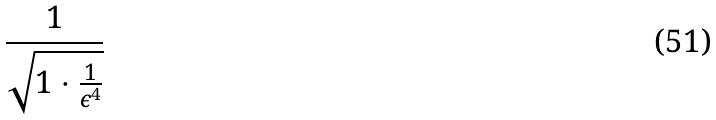<formula> <loc_0><loc_0><loc_500><loc_500>\frac { 1 } { \sqrt { 1 \cdot \frac { 1 } { \epsilon ^ { 4 } } } }</formula> 